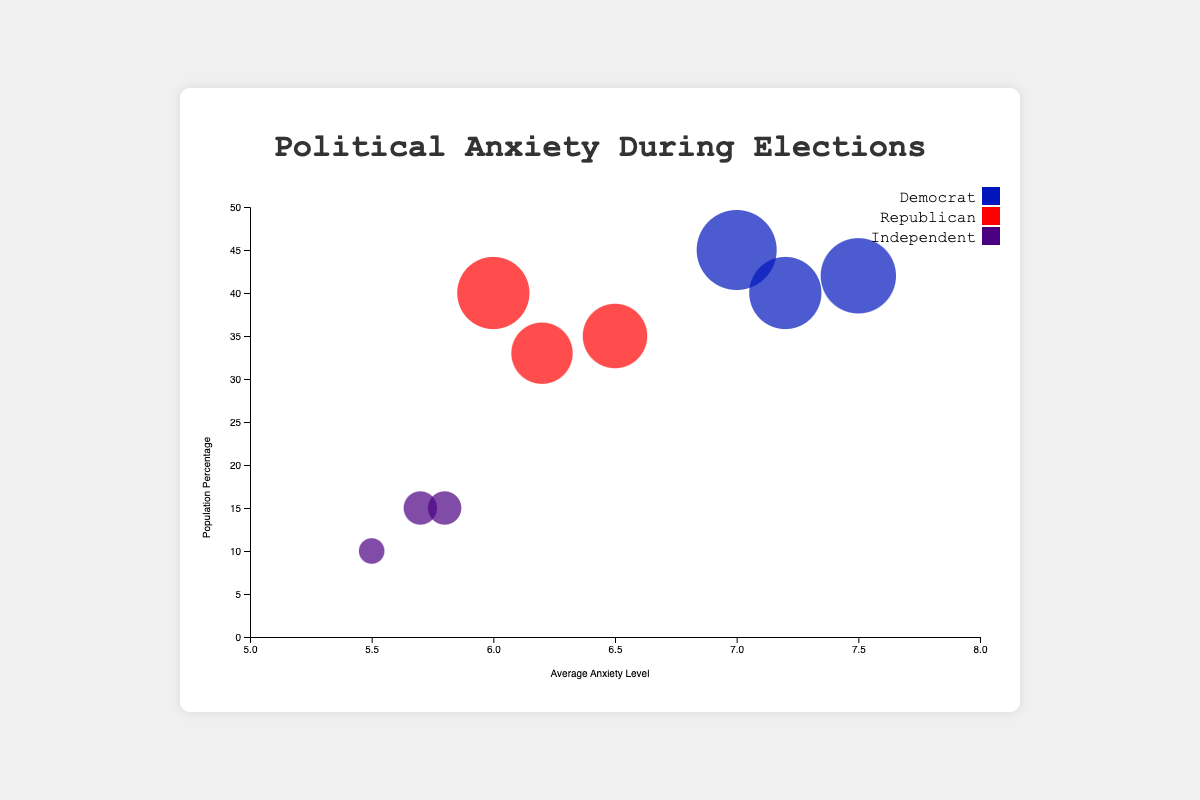What's the title of the figure? The title is displayed at the center of the top part of the figure. It usually provides an overview or description of the data being visualized.
Answer: Political Anxiety During Elections What are the axes labels in the chart? The label of the horizontal axis indicates the metric being measured along this dimension, and the label of the vertical axis indicates the metric being measured along that dimension. In this chart, the x-axis is labeled "Average Anxiety Level" and the y-axis is labeled "Population Percentage".
Answer: "Average Anxiety Level" and "Population Percentage" How many data points are there for each election period? The total number of data points for each election period can be counted by noting the number of circles representing different political affiliations for that period. Each election period (2008, 2016, 2020) has three data points corresponding to Democrats, Republicans, and Independents.
Answer: 3 per period Which political affiliation shows the highest average anxiety level in the 2020 Presidential Election? Looking at the bubbles representing different political affiliations in the 2020 Presidential Election period, we can compare their positions along the x-axis to determine which is highest. The Democrat bubble is furthest to the right.
Answer: Democrat Between which two election periods did the Republican average anxiety level show the highest increase? To find this, we compare the Republican anxiety levels between election years: 2008 (6.2), 2016 (6.0), and 2020 (6.5). The largest increase is between 2016 and 2020.
Answer: 2016 and 2020 What is the combined population percentage for Independents in all election periods? Add up the population percentages for Independents across all provided election periods: 15 (2008) + 10 (2016) + 15 (2020). The total is 40%.
Answer: 40% Compare and contrast the population percentage of Democrats in 2008 and 2020. Evaluating the heights of the Democrat bubbles, the population percentage for Democrats in 2008 is 42%, whereas in 2020 it is 40%. 2008 is slightly higher.
Answer: 2008 is higher What period shows the lowest average anxiety level among Independents? We check the average anxiety levels of Independents across all periods: 2008 (5.7), 2016 (5.5), and 2020 (5.8). 2016 has the lowest.
Answer: 2016 How does the size of the bubble represent the population percentage? The size of the bubbles correlates with the population percentage; larger bubbles indicate higher percentages. This can be visually approximated by comparing the sizes of bubbles across different political affiliations and election periods.
Answer: Larger bubbles indicate higher percentages Between 2008 and 2020, how did the average anxiety level of Democrats change? By comparing the x-axis positions of Democrat bubbles in 2008 (7.5) and 2020 (7.2), we see a decrease in the average anxiety level of Democrats.
Answer: Decreased 